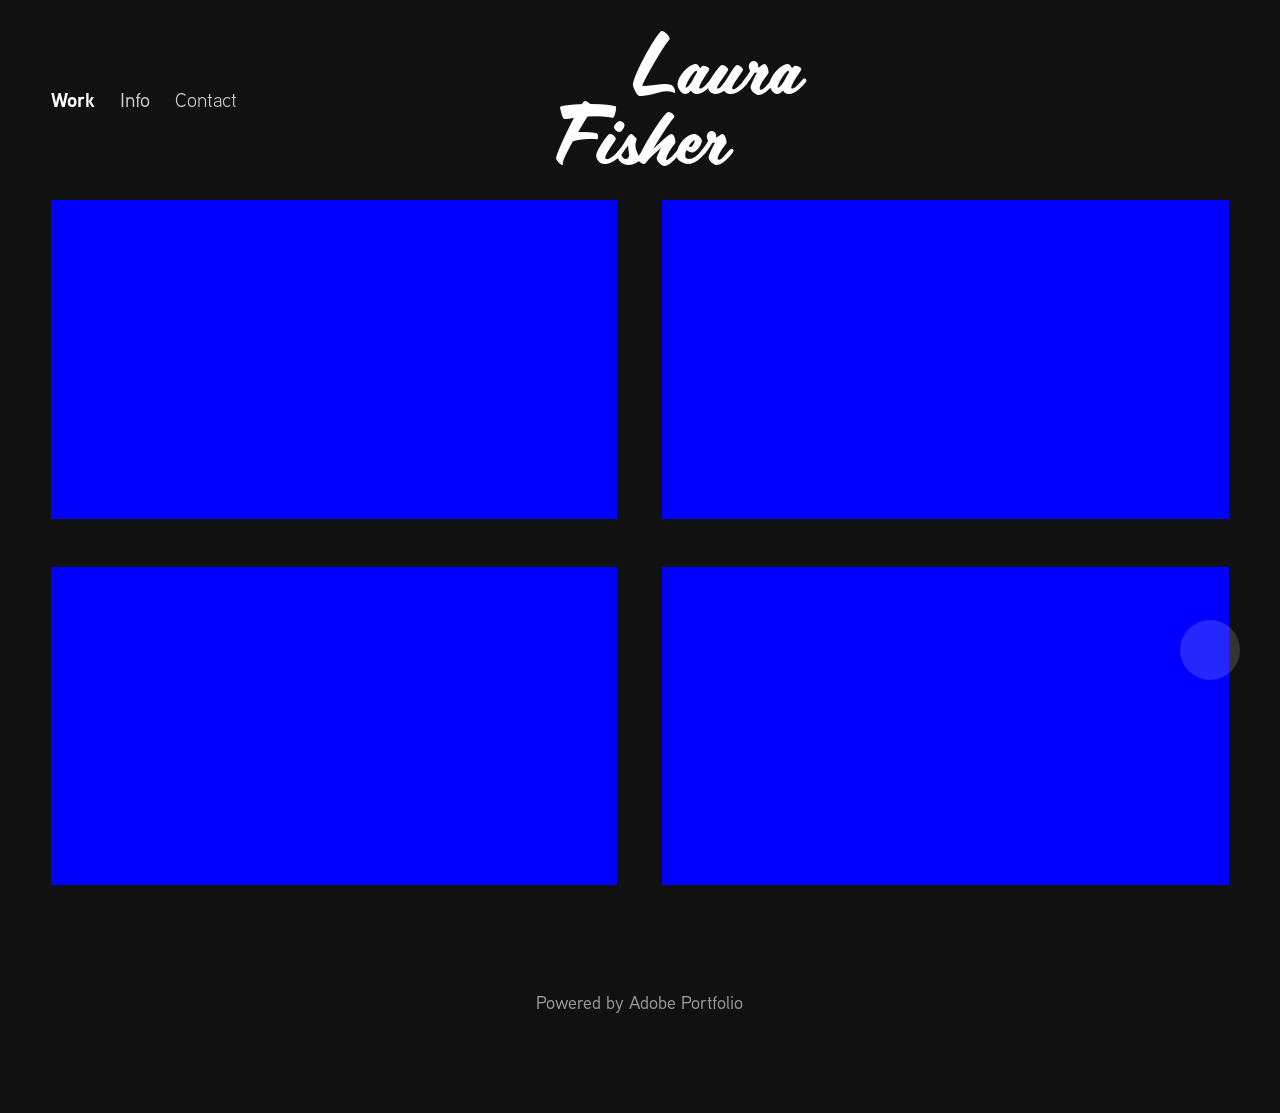What are some potential thematic categories Laura Fisher might consider for organizing the 'Work' section on her website? Laura Fisher could organize her 'Work' section by thematic categories like 'Abstract Expression', 'Color Studies', 'Digital Illustration', or by medium such as 'Watercolors', 'Acrylics', and 'Mixed Media'. Additionally, organizing by series or time periods could help visitors navigate her portfolio more effectively. 